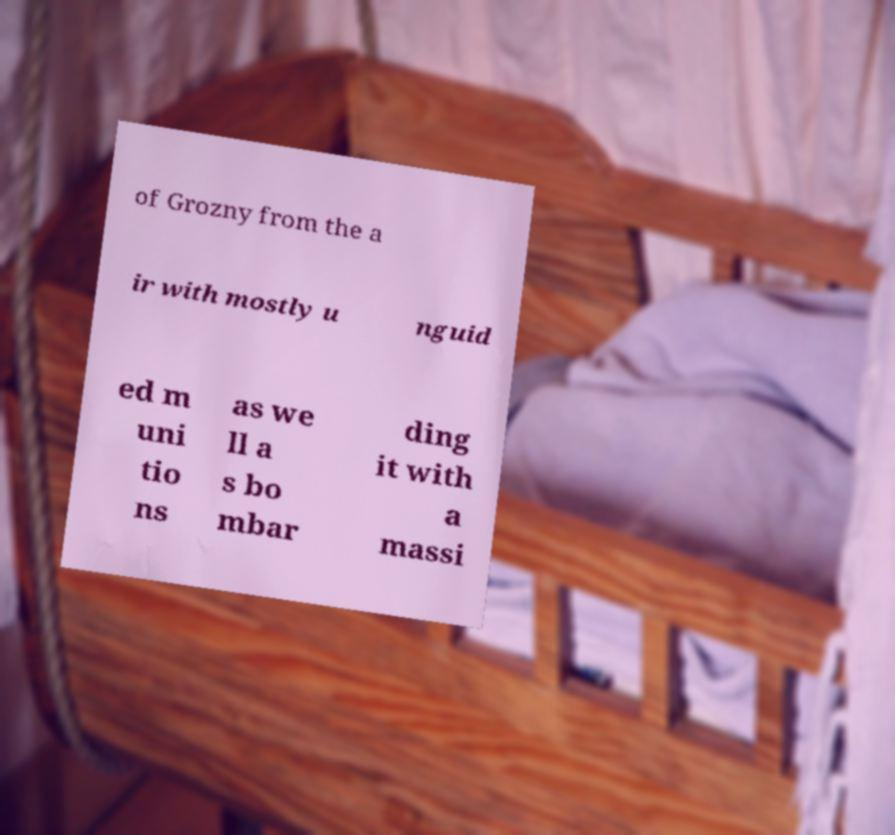I need the written content from this picture converted into text. Can you do that? of Grozny from the a ir with mostly u nguid ed m uni tio ns as we ll a s bo mbar ding it with a massi 